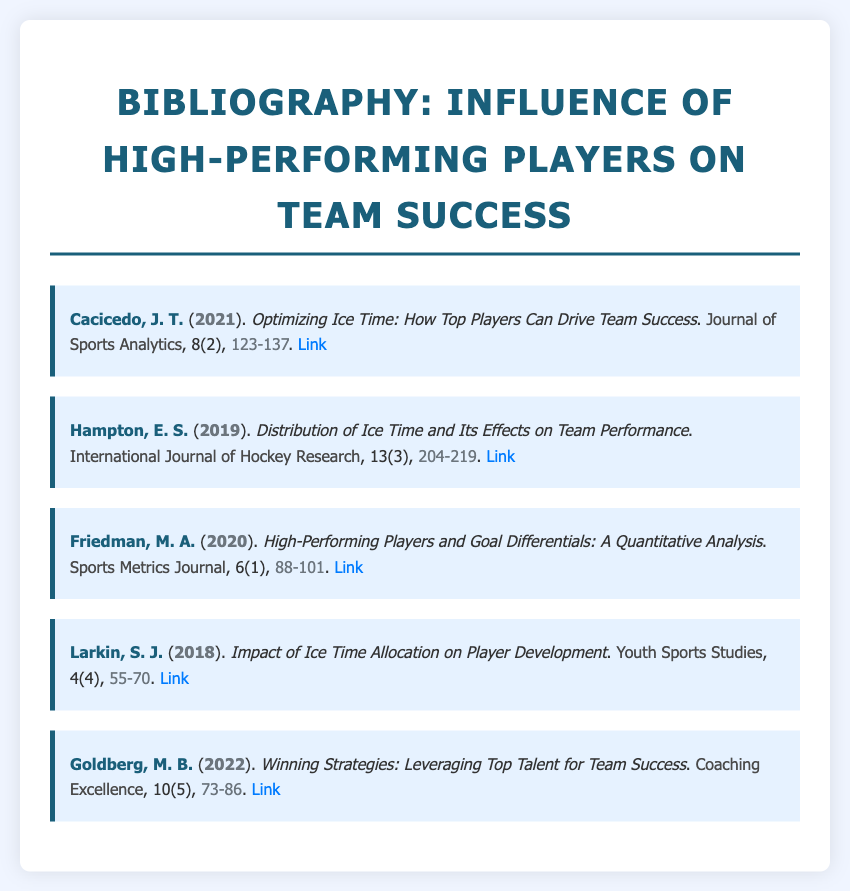What is the title of the document? The title is prominently displayed at the top of the document, indicating the main focus of the bibliography.
Answer: Influence of High-Performing Players on Team Success Who authored the article about optimizing ice time? The author information for each article is listed alongside the title, providing clear attribution.
Answer: Cacicedo, J. T In which year was the article on player development published? The year of publication is specified in parentheses after each author's name, indicating when the research was conducted.
Answer: 2018 What is the volume number of the article on goal differentials? The volume number is provided within the bibliographic details, which assists in locating the articles in their respective journals.
Answer: 6 Which journal published the article titled "Winning Strategies: Leveraging Top Talent for Team Success"? The name of the journal is given in bold text within the bibliographic entry and indicates where the research was published.
Answer: Coaching Excellence How many pages does the article by Hampton cover? The page range at the end of each bibliographic entry shows the length of the article in the journal.
Answer: 204-219 What is the relationship highlighted in Larkin's article? The title gives insights into the focus of the article and hints at the correlation being explored regarding player development and ice time allocation.
Answer: Impact of Ice Time Allocation on Player Development Which article discusses the effects of ice time distribution? The titles explicitly state the focus of each article, indicating their specific research topics.
Answer: Distribution of Ice Time and Its Effects on Team Performance 